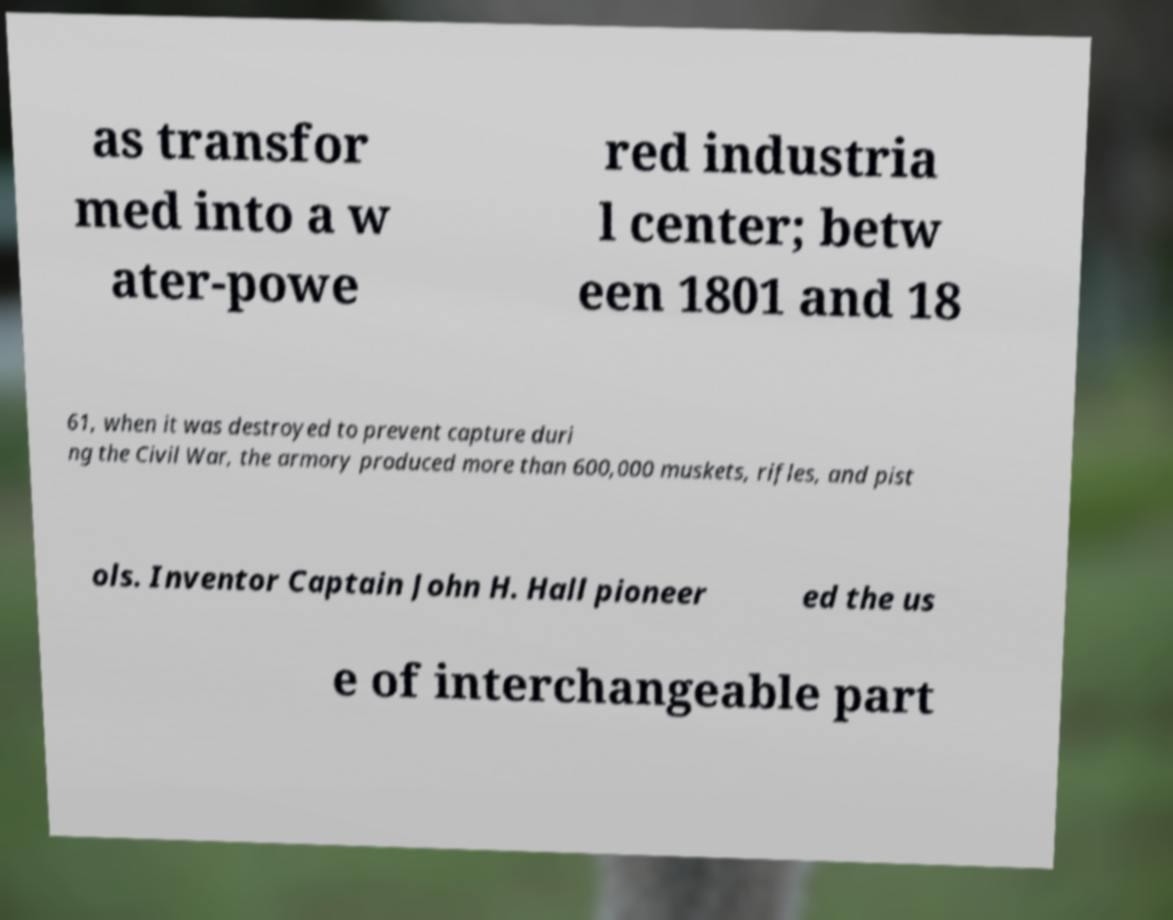I need the written content from this picture converted into text. Can you do that? as transfor med into a w ater-powe red industria l center; betw een 1801 and 18 61, when it was destroyed to prevent capture duri ng the Civil War, the armory produced more than 600,000 muskets, rifles, and pist ols. Inventor Captain John H. Hall pioneer ed the us e of interchangeable part 